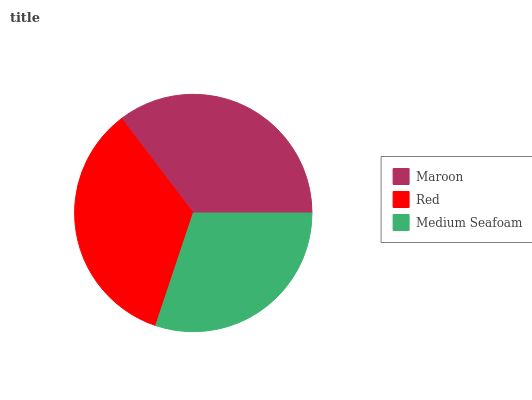Is Medium Seafoam the minimum?
Answer yes or no. Yes. Is Maroon the maximum?
Answer yes or no. Yes. Is Red the minimum?
Answer yes or no. No. Is Red the maximum?
Answer yes or no. No. Is Maroon greater than Red?
Answer yes or no. Yes. Is Red less than Maroon?
Answer yes or no. Yes. Is Red greater than Maroon?
Answer yes or no. No. Is Maroon less than Red?
Answer yes or no. No. Is Red the high median?
Answer yes or no. Yes. Is Red the low median?
Answer yes or no. Yes. Is Medium Seafoam the high median?
Answer yes or no. No. Is Maroon the low median?
Answer yes or no. No. 